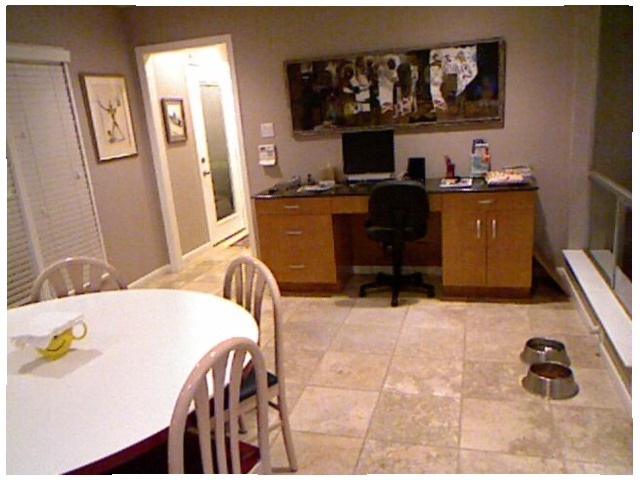<image>
Is there a chair in front of the chair? No. The chair is not in front of the chair. The spatial positioning shows a different relationship between these objects. Is the cupboard above the photo frame? Yes. The cupboard is positioned above the photo frame in the vertical space, higher up in the scene. Where is the picture in relation to the wall? Is it on the wall? No. The picture is not positioned on the wall. They may be near each other, but the picture is not supported by or resting on top of the wall. Is the chair under the table? Yes. The chair is positioned underneath the table, with the table above it in the vertical space. 